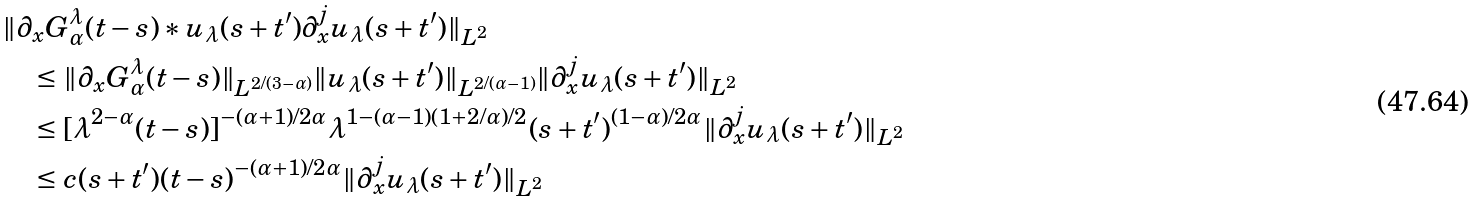Convert formula to latex. <formula><loc_0><loc_0><loc_500><loc_500>& \| \partial _ { x } G _ { \alpha } ^ { \lambda } ( t - s ) \ast u _ { \lambda } ( s + t ^ { \prime } ) \partial _ { x } ^ { j } u _ { \lambda } ( s + t ^ { \prime } ) \| _ { L ^ { 2 } } \\ & \quad \leq \| \partial _ { x } G _ { \alpha } ^ { \lambda } ( t - s ) \| _ { L ^ { 2 / ( 3 - \alpha ) } } \| u _ { \lambda } ( s + t ^ { \prime } ) \| _ { L ^ { 2 / ( \alpha - 1 ) } } \| \partial _ { x } ^ { j } u _ { \lambda } ( s + t ^ { \prime } ) \| _ { L ^ { 2 } } \\ & \quad \leq [ \lambda ^ { 2 - \alpha } ( t - s ) ] ^ { - ( \alpha + 1 ) / 2 \alpha } \lambda ^ { 1 - ( \alpha - 1 ) ( 1 + 2 / \alpha ) / 2 } ( s + t ^ { \prime } ) ^ { ( 1 - \alpha ) / 2 \alpha } \| \partial _ { x } ^ { j } u _ { \lambda } ( s + t ^ { \prime } ) \| _ { L ^ { 2 } } \\ & \quad \leq c ( s + t ^ { \prime } ) ( t - s ) ^ { - ( \alpha + 1 ) / 2 \alpha } \| \partial _ { x } ^ { j } u _ { \lambda } ( s + t ^ { \prime } ) \| _ { L ^ { 2 } }</formula> 